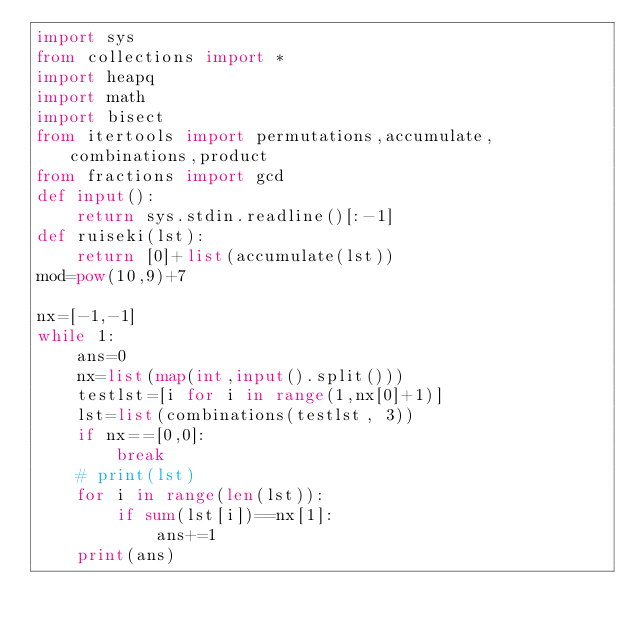<code> <loc_0><loc_0><loc_500><loc_500><_Python_>import sys
from collections import *
import heapq
import math
import bisect
from itertools import permutations,accumulate,combinations,product
from fractions import gcd
def input():
    return sys.stdin.readline()[:-1]
def ruiseki(lst):
    return [0]+list(accumulate(lst))
mod=pow(10,9)+7

nx=[-1,-1]
while 1:
    ans=0
    nx=list(map(int,input().split()))
    testlst=[i for i in range(1,nx[0]+1)]
    lst=list(combinations(testlst, 3))
    if nx==[0,0]:
        break
    # print(lst)
    for i in range(len(lst)):
        if sum(lst[i])==nx[1]:
            ans+=1
    print(ans)
</code> 